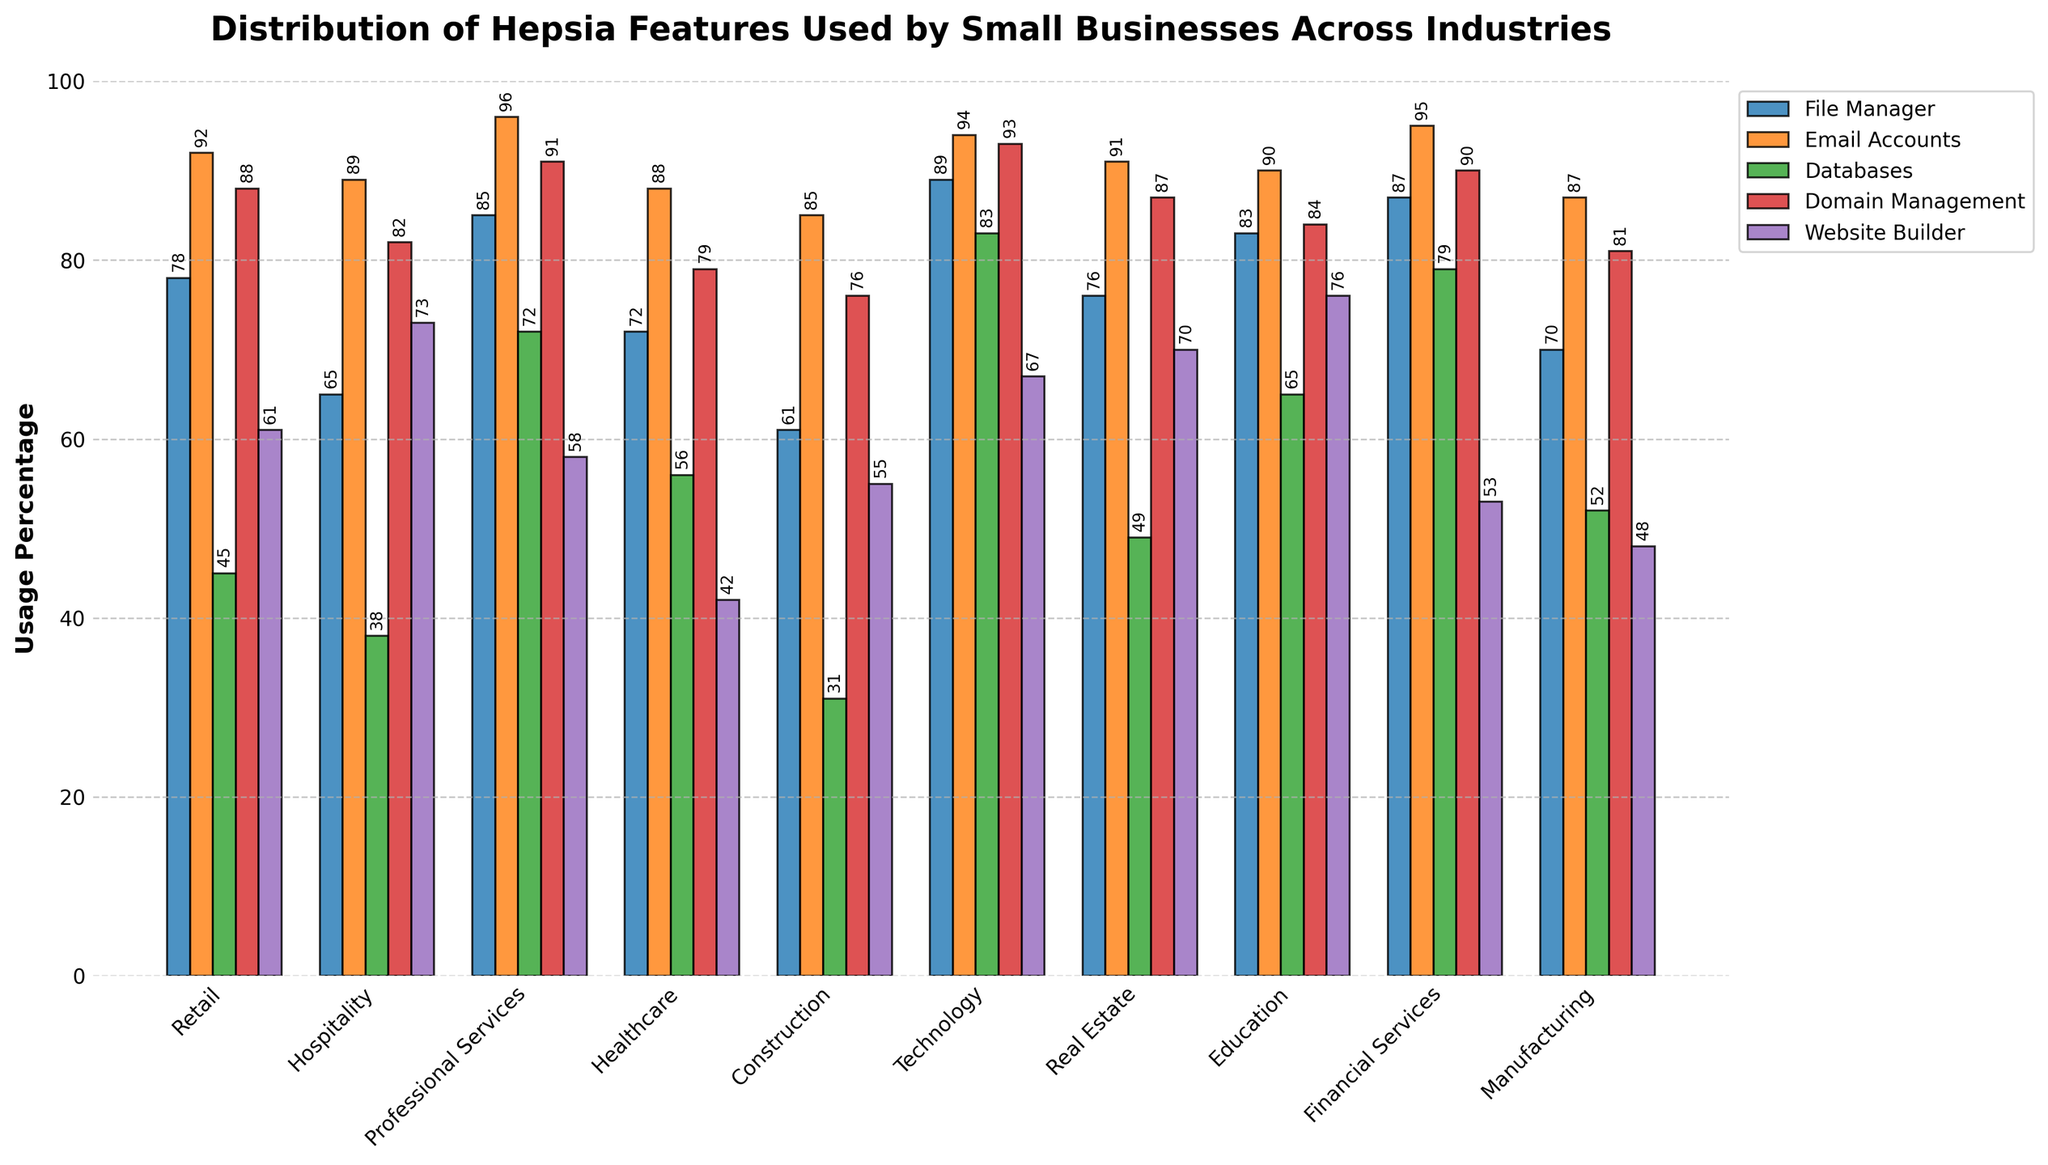Which industry uses the File Manager feature the most? By looking at the height of the bars representing File Manager usage across all industries, the Technology industry has the highest bar.
Answer: Technology How much more does the Financial Services industry use the Databases feature compared to the Healthcare industry? The usage of Databases in Financial Services is 79, and in Healthcare is 56. The difference is 79 - 56 = 23.
Answer: 23 Which two industries have the same usage percentage for Email Accounts? The bars for Retail and Real Estate show the same height for the Email Accounts feature. Both industries have a usage percentage of 91.
Answer: Retail, Real Estate What is the average usage of the Website Builder feature across all industries? Add the values of Website Builder for all industries (61 + 73 + 58 + 42 + 55 + 67 + 70 + 76 + 53 + 48) = 603, then divide by the number of industries (10). The average is 603 / 10 = 60.3.
Answer: 60.3 Which industry has the lowest usage of Domain Management, and what is its value? By observing the heights of the bars representing Domain Management usage, the Construction industry has the lowest bar with a value of 76.
Answer: Construction, 76 Is the usage of Databases in the Technology industry greater than the combined usage in Retail and Hospitality? The usage of Databases in Technology is 83. The combined usage in Retail and Hospitality is 45 + 38 = 83. Since 83 is equal to 83, the answer is no.
Answer: No What is the difference in File Manager usage between the top two industries? The top two industries for File Manager usage are Technology (89) and Professional Services (85). The difference is 89 - 85 = 4.
Answer: 4 Which industry uses the most features, and what are those features? By observing the heights of all the bars for each industry, the Technology industry has the highest usage percentages for File Manager, Domain Management, and Databases.
Answer: Technology, File Manager, Domain Management, Databases 